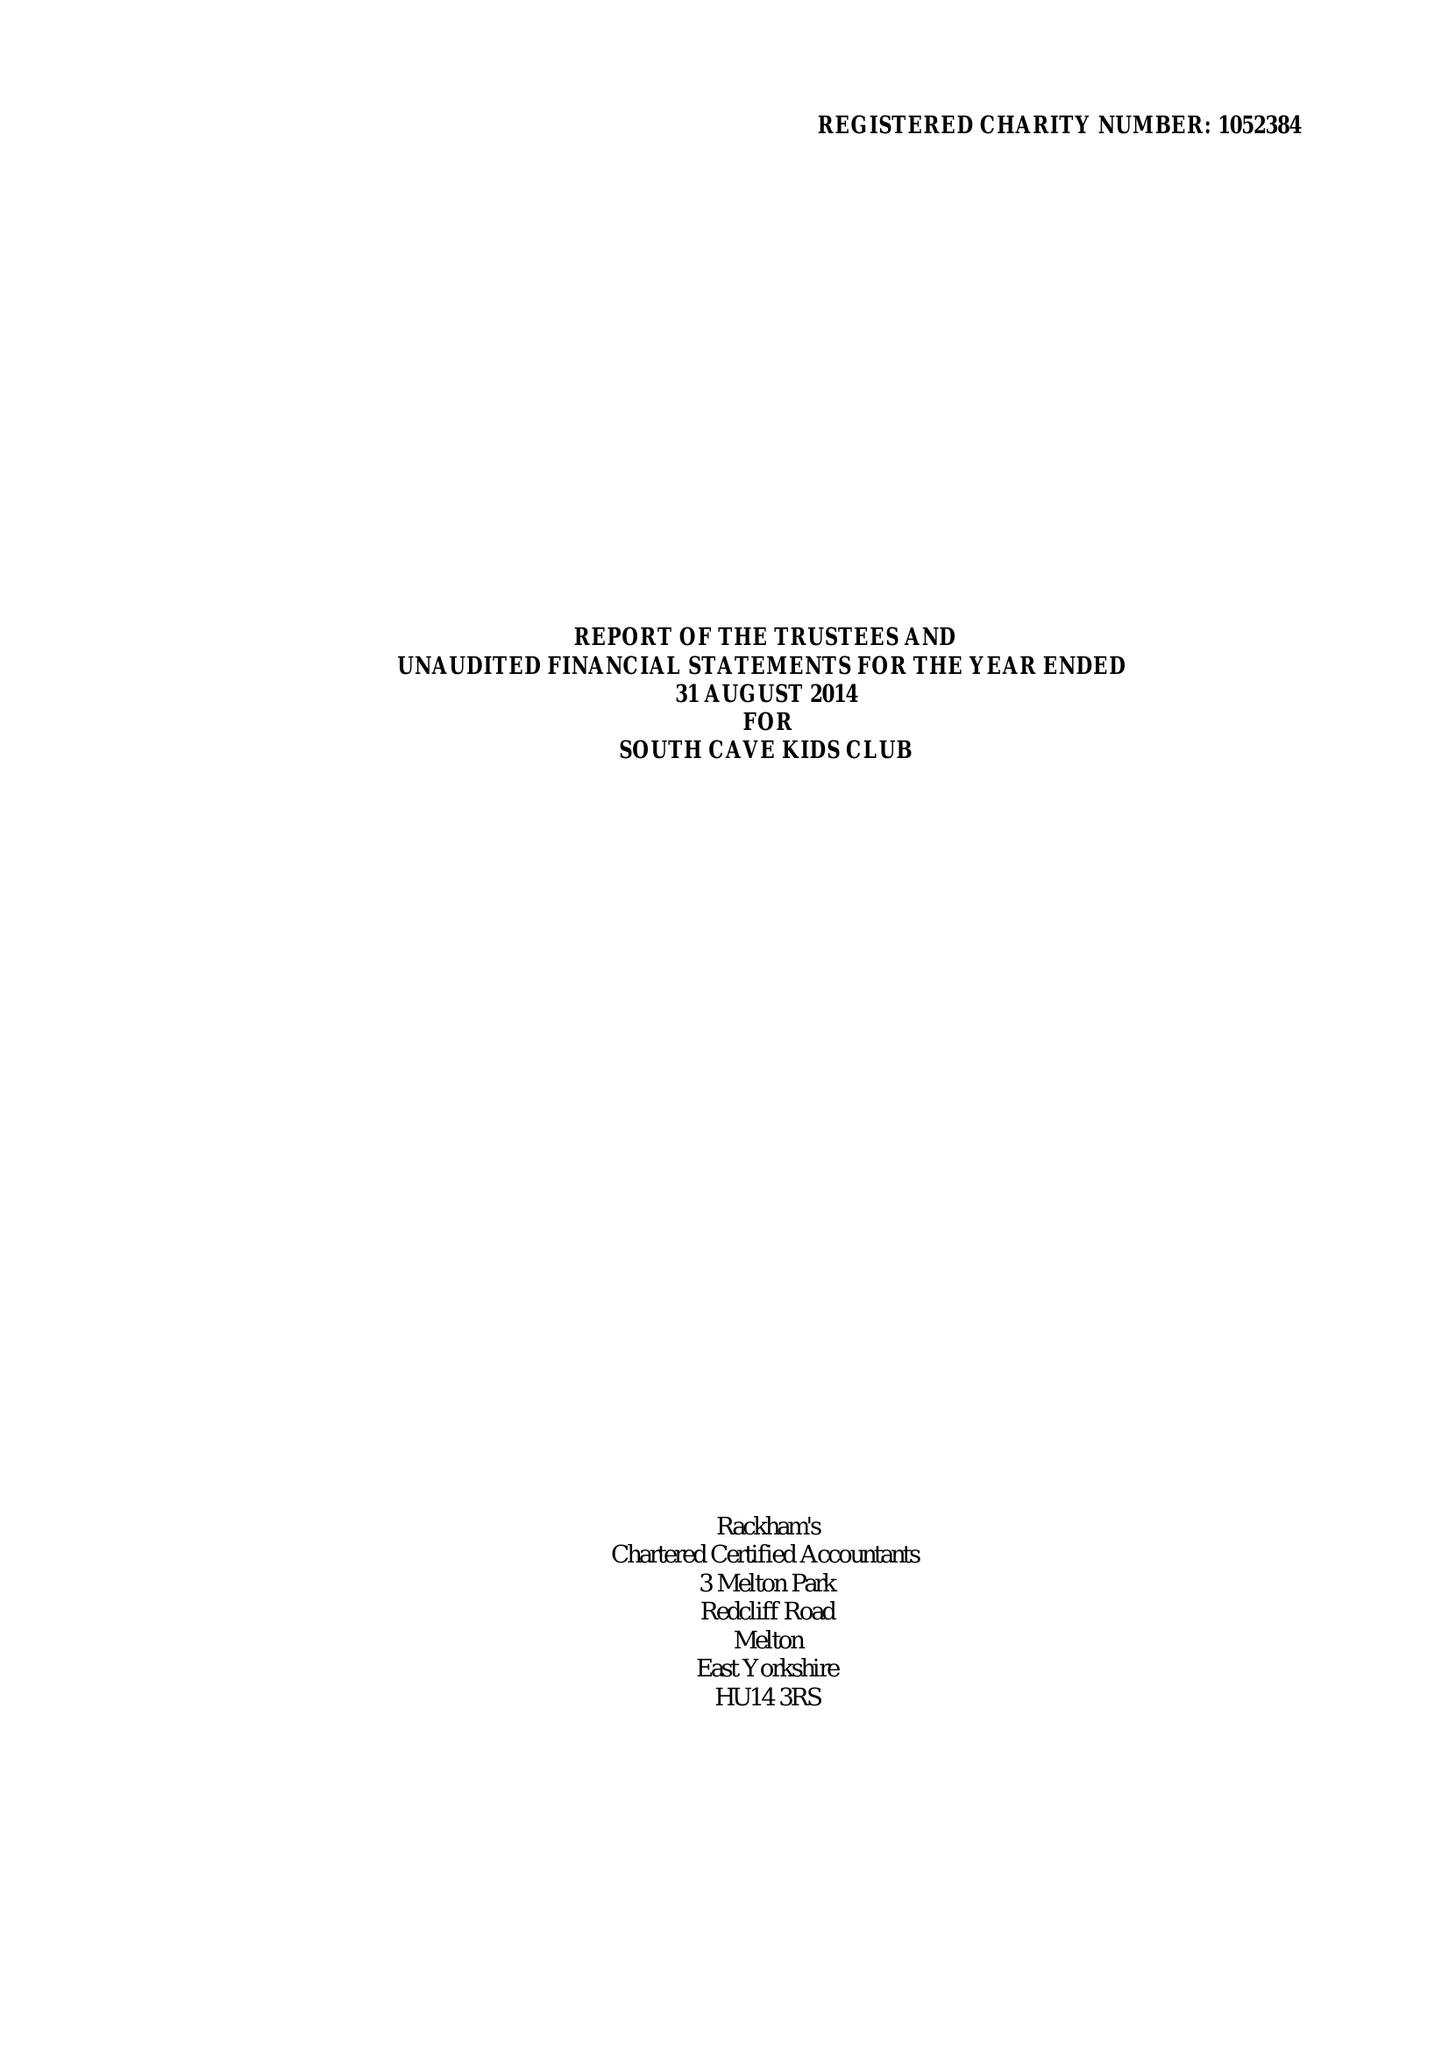What is the value for the address__street_line?
Answer the question using a single word or phrase. CHURCH STREET 